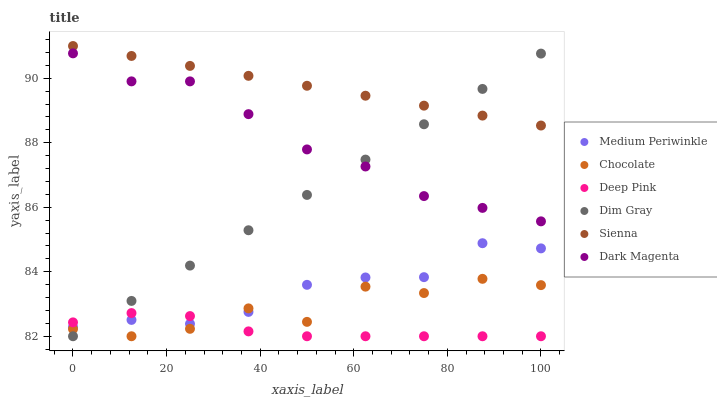Does Deep Pink have the minimum area under the curve?
Answer yes or no. Yes. Does Sienna have the maximum area under the curve?
Answer yes or no. Yes. Does Dark Magenta have the minimum area under the curve?
Answer yes or no. No. Does Dark Magenta have the maximum area under the curve?
Answer yes or no. No. Is Sienna the smoothest?
Answer yes or no. Yes. Is Chocolate the roughest?
Answer yes or no. Yes. Is Dark Magenta the smoothest?
Answer yes or no. No. Is Dark Magenta the roughest?
Answer yes or no. No. Does Dim Gray have the lowest value?
Answer yes or no. Yes. Does Dark Magenta have the lowest value?
Answer yes or no. No. Does Sienna have the highest value?
Answer yes or no. Yes. Does Dark Magenta have the highest value?
Answer yes or no. No. Is Deep Pink less than Dark Magenta?
Answer yes or no. Yes. Is Dark Magenta greater than Deep Pink?
Answer yes or no. Yes. Does Sienna intersect Dim Gray?
Answer yes or no. Yes. Is Sienna less than Dim Gray?
Answer yes or no. No. Is Sienna greater than Dim Gray?
Answer yes or no. No. Does Deep Pink intersect Dark Magenta?
Answer yes or no. No. 